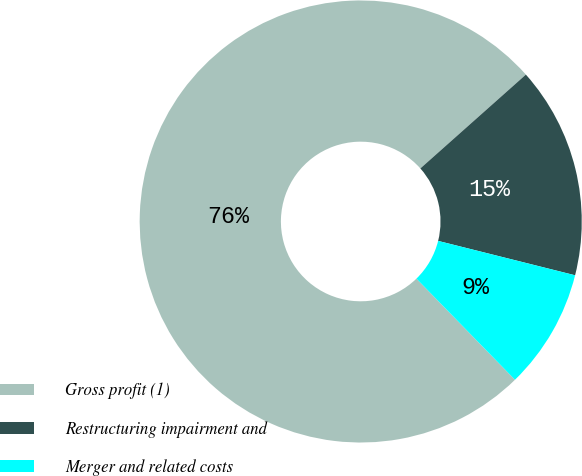<chart> <loc_0><loc_0><loc_500><loc_500><pie_chart><fcel>Gross profit (1)<fcel>Restructuring impairment and<fcel>Merger and related costs<nl><fcel>75.72%<fcel>15.48%<fcel>8.79%<nl></chart> 